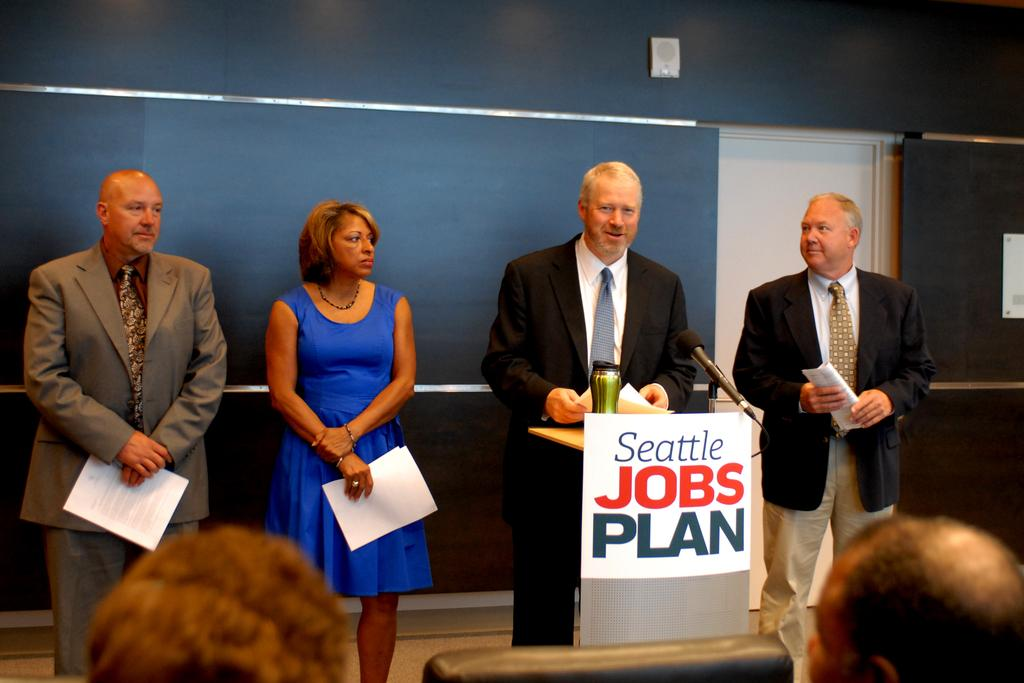What can be observed about the people in the image? There are persons wearing clothes in the image. Can you describe the position of one of the persons in the image? There is a person standing in the middle of the image. What can be seen in the background of the image? There is a wall visible in the background of the image. How many dolls are sitting on the wall in the image? There are no dolls present in the image; it features persons wearing clothes and a wall in the background. What type of fairies can be seen flying around the person in the middle of the image? There are no fairies present in the image; it only features persons wearing clothes and a wall in the background. 